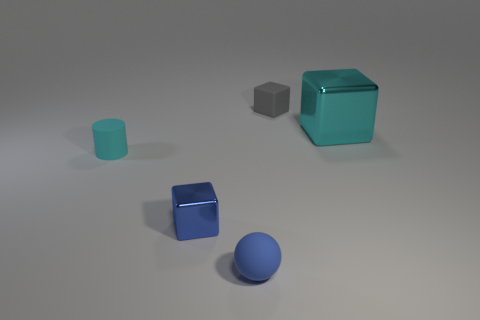Is there any other thing that has the same size as the cyan metal thing?
Your answer should be very brief. No. There is a object that is the same color as the large metallic cube; what material is it?
Keep it short and to the point. Rubber. There is a small cylinder; does it have the same color as the block on the right side of the gray cube?
Offer a very short reply. Yes. How many things are either tiny cyan cylinders or tiny blue things?
Provide a short and direct response. 3. What is the material of the cyan object that is the same size as the gray object?
Provide a short and direct response. Rubber. There is a metallic cube on the right side of the tiny blue metallic thing; what is its size?
Provide a short and direct response. Large. What material is the small gray block?
Your response must be concise. Rubber. How many things are blocks that are to the left of the small gray thing or cubes that are to the left of the big cyan thing?
Keep it short and to the point. 2. What number of other objects are the same color as the tiny cylinder?
Offer a very short reply. 1. There is a large thing; is it the same shape as the cyan thing that is in front of the big cyan cube?
Ensure brevity in your answer.  No. 